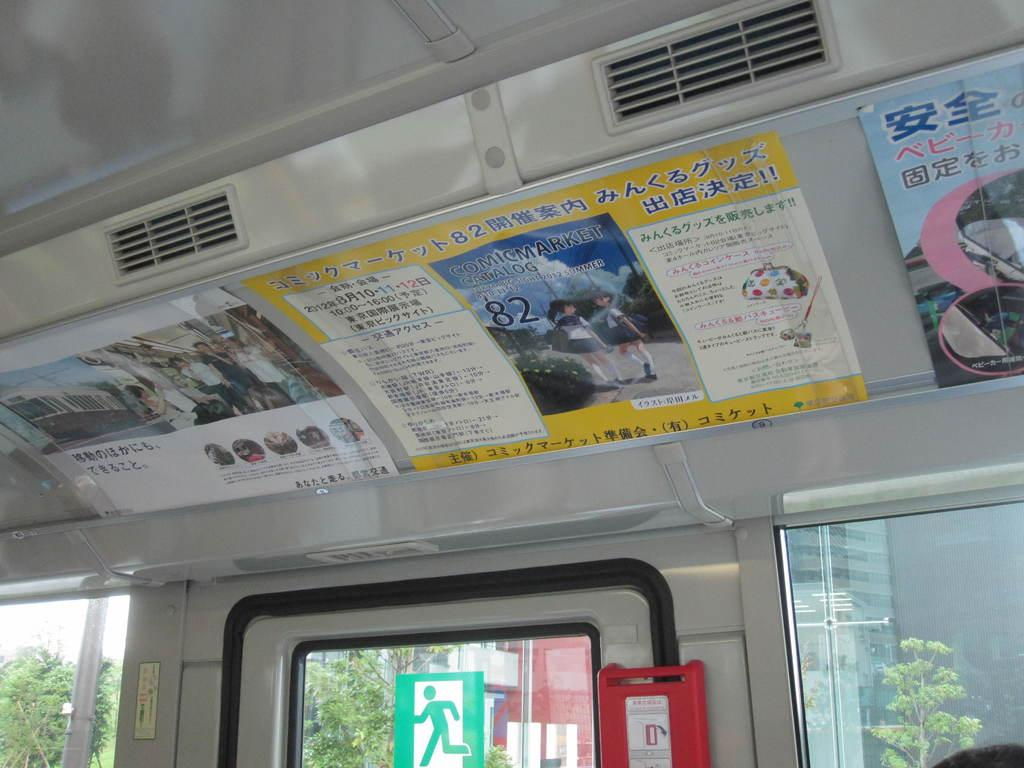Where was the image taken? The image was taken inside a vehicle. What can be seen on the walls of the vehicle? There are many posters in the vehicle. What is the primary source of light in the vehicle? The glass window in the vehicle allows natural light to enter. What can be seen outside the vehicle through the window? Trees, buildings, a sign board, and the sky are visible outside through the window. What type of gold jewelry is the owner wearing in the image? There is no owner or gold jewelry visible in the image; it was taken inside a vehicle with a view of the outside. 